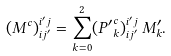<formula> <loc_0><loc_0><loc_500><loc_500>( M ^ { c } ) _ { i j ^ { \prime } } ^ { i ^ { \prime } j } = \sum _ { k = 0 } ^ { 2 } ( { P ^ { \prime } } _ { k } ^ { c } ) _ { i j ^ { \prime } } ^ { i ^ { \prime } j } \, M _ { k } ^ { \prime } .</formula> 